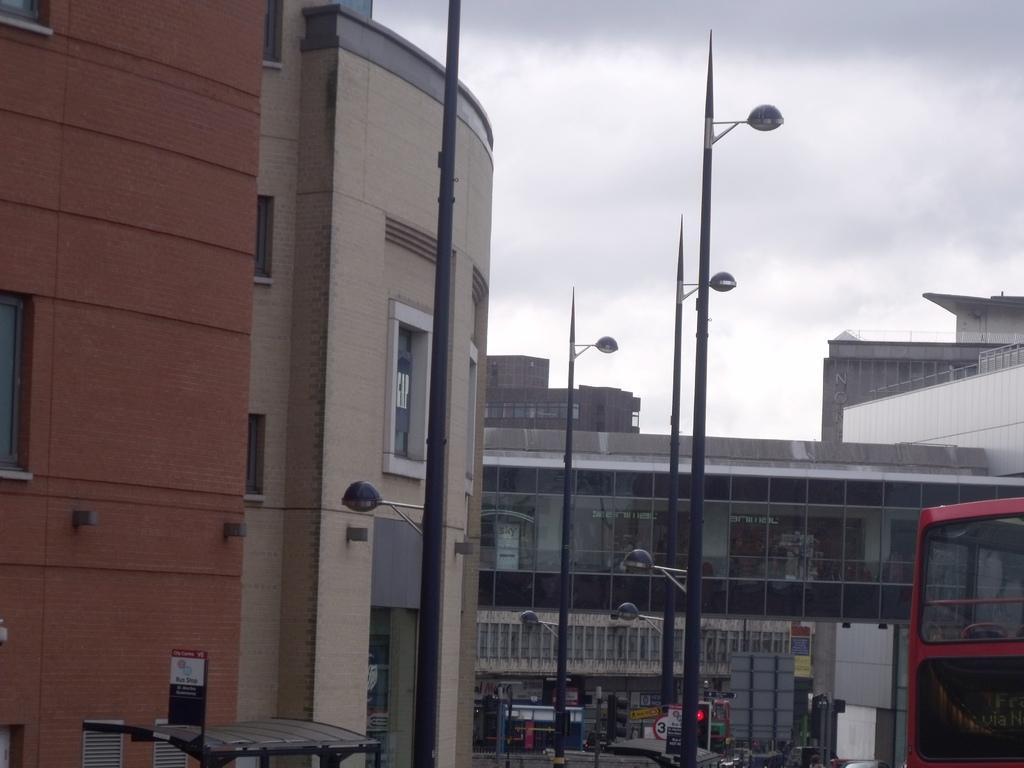Describe this image in one or two sentences. We can see lights,boards and traffic signals on poles. We can see vehicle and buildings. On the left side of the image we can see board on the shed. In the background we can see sky with clouds. 